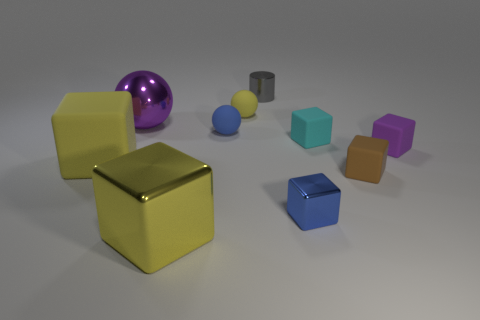Subtract all tiny brown cubes. How many cubes are left? 5 Subtract 0 purple cylinders. How many objects are left? 10 Subtract all balls. How many objects are left? 7 Subtract all purple balls. Subtract all gray cylinders. How many balls are left? 2 Subtract all cyan cubes. How many brown balls are left? 0 Subtract all blue matte spheres. Subtract all small cyan matte blocks. How many objects are left? 8 Add 9 cylinders. How many cylinders are left? 10 Add 8 large yellow cubes. How many large yellow cubes exist? 10 Subtract all brown cubes. How many cubes are left? 5 